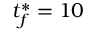Convert formula to latex. <formula><loc_0><loc_0><loc_500><loc_500>t _ { f } ^ { \ast } = 1 0</formula> 